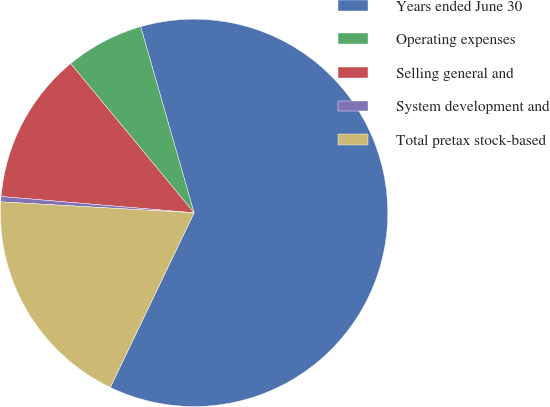Convert chart to OTSL. <chart><loc_0><loc_0><loc_500><loc_500><pie_chart><fcel>Years ended June 30<fcel>Operating expenses<fcel>Selling general and<fcel>System development and<fcel>Total pretax stock-based<nl><fcel>61.57%<fcel>6.55%<fcel>12.66%<fcel>0.44%<fcel>18.78%<nl></chart> 